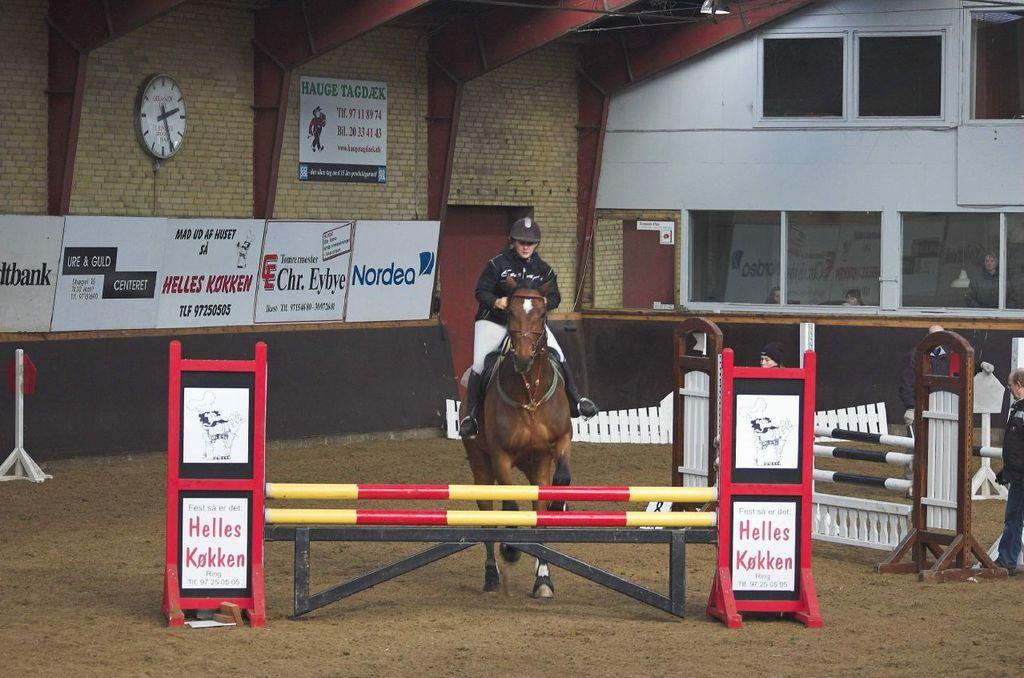What is the man in the image doing? The man is sitting on a horse in the image. What can be seen in the image besides the man on the horse? There are barricades, posters, a wall clock, and people inside a building in the image. What is the man standing in the image doing? There is no information about the man standing in the image, as the facts only mention the man on the horse. What type of board is being used to create a boundary in the image? There is no board or boundary present in the image. What kind of soap is being advertised on the posters in the image? There is no soap or advertisement mentioned in the image. 